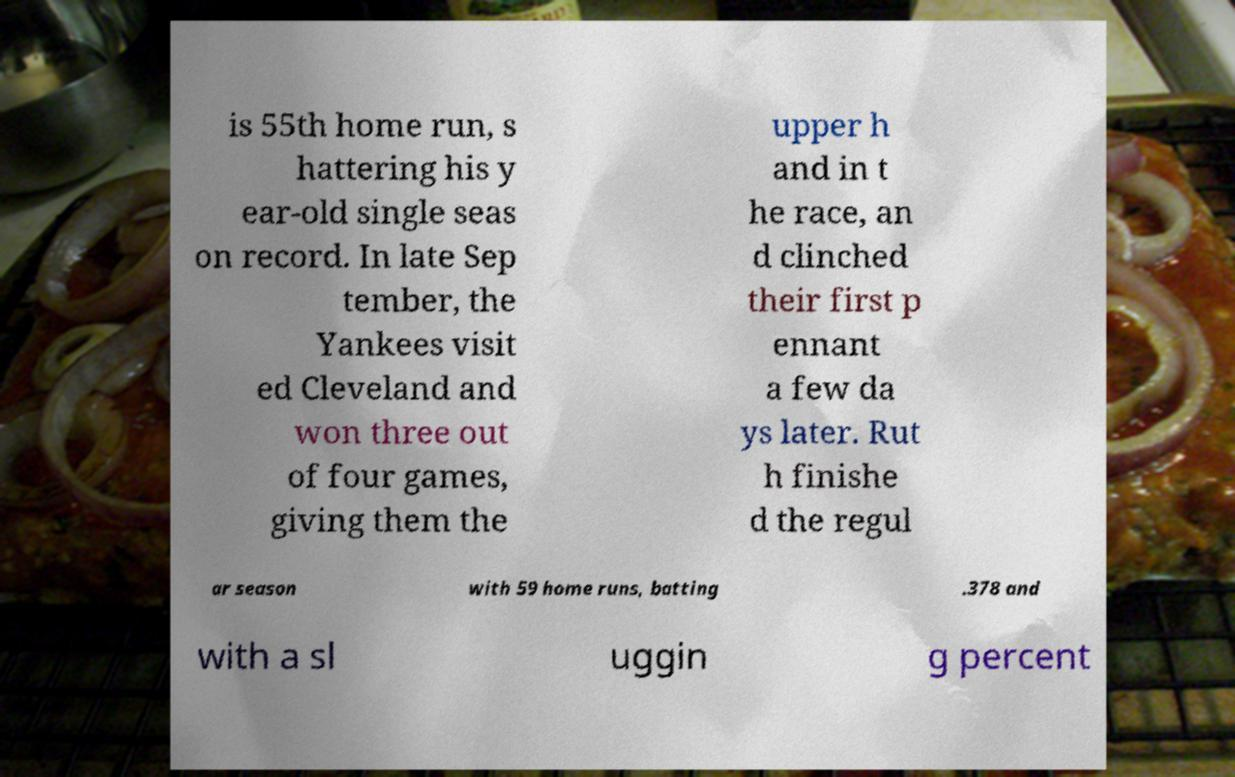Can you read and provide the text displayed in the image?This photo seems to have some interesting text. Can you extract and type it out for me? is 55th home run, s hattering his y ear-old single seas on record. In late Sep tember, the Yankees visit ed Cleveland and won three out of four games, giving them the upper h and in t he race, an d clinched their first p ennant a few da ys later. Rut h finishe d the regul ar season with 59 home runs, batting .378 and with a sl uggin g percent 